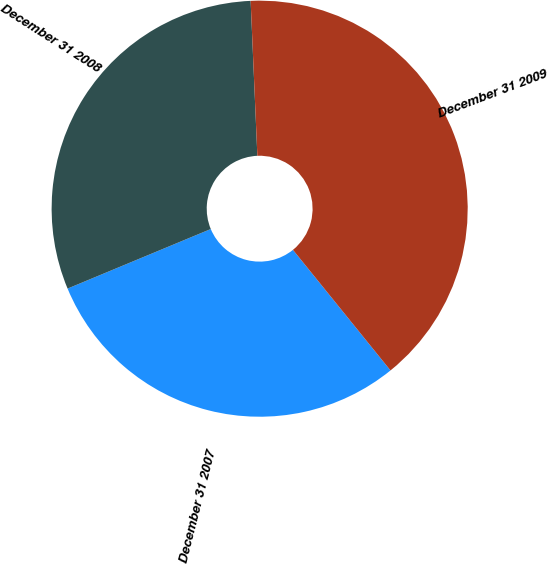Convert chart. <chart><loc_0><loc_0><loc_500><loc_500><pie_chart><fcel>December 31 2007<fcel>December 31 2008<fcel>December 31 2009<nl><fcel>29.55%<fcel>30.58%<fcel>39.86%<nl></chart> 